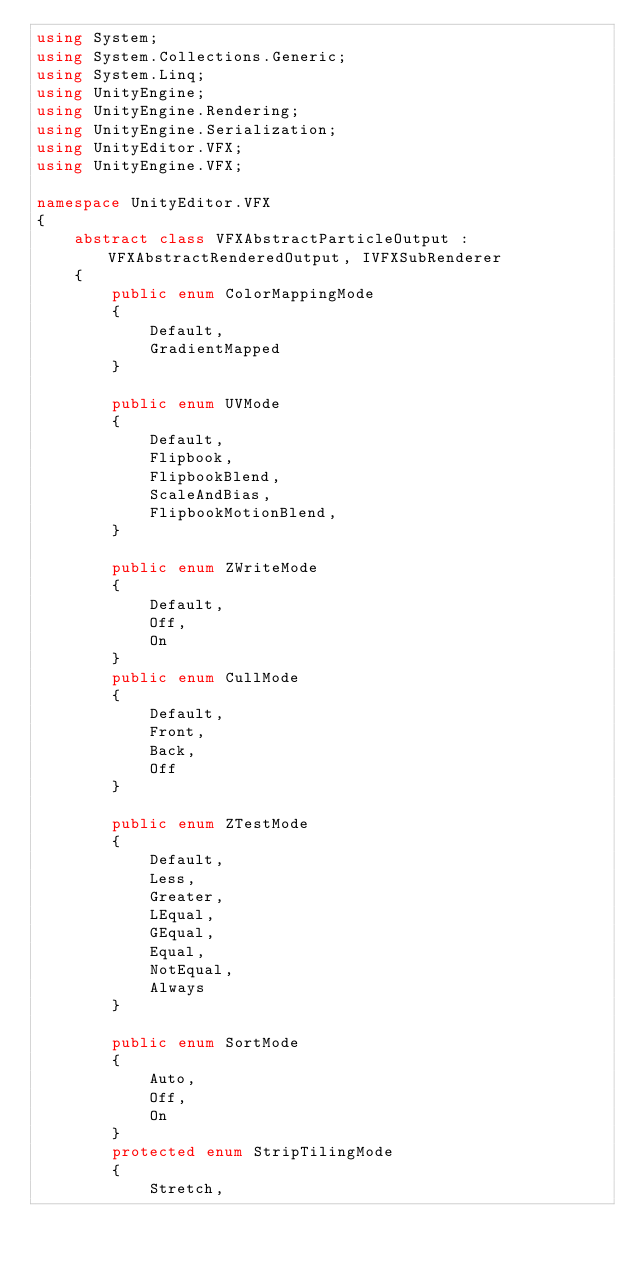Convert code to text. <code><loc_0><loc_0><loc_500><loc_500><_C#_>using System;
using System.Collections.Generic;
using System.Linq;
using UnityEngine;
using UnityEngine.Rendering;
using UnityEngine.Serialization;
using UnityEditor.VFX;
using UnityEngine.VFX;

namespace UnityEditor.VFX
{
    abstract class VFXAbstractParticleOutput : VFXAbstractRenderedOutput, IVFXSubRenderer
    {
        public enum ColorMappingMode
        {
            Default,
            GradientMapped
        }

        public enum UVMode
        {
            Default,
            Flipbook,
            FlipbookBlend,
            ScaleAndBias,
            FlipbookMotionBlend,
        }

        public enum ZWriteMode
        {
            Default,
            Off,
            On
        }
        public enum CullMode
        {
            Default,
            Front,
            Back,
            Off
        }

        public enum ZTestMode
        {
            Default,
            Less,
            Greater,
            LEqual,
            GEqual,
            Equal,
            NotEqual,
            Always
        }

        public enum SortMode
        {
            Auto,
            Off,
            On
        }
        protected enum StripTilingMode
        {
            Stretch,</code> 